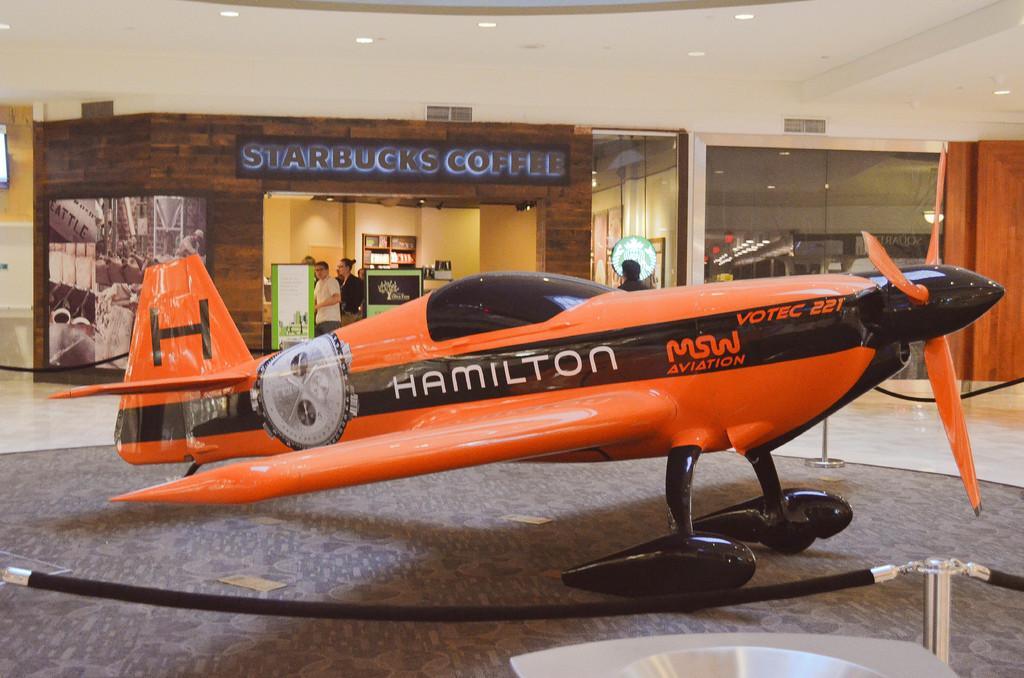Describe this image in one or two sentences. In this picture we can see an airplane on the ground, fence and in the background we can see banners, lights and some persons standing. 